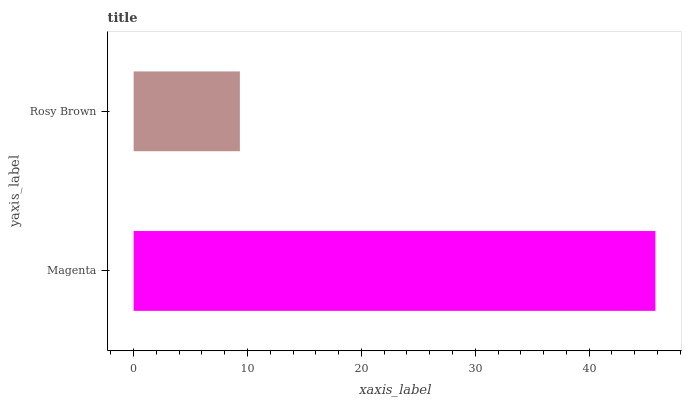Is Rosy Brown the minimum?
Answer yes or no. Yes. Is Magenta the maximum?
Answer yes or no. Yes. Is Rosy Brown the maximum?
Answer yes or no. No. Is Magenta greater than Rosy Brown?
Answer yes or no. Yes. Is Rosy Brown less than Magenta?
Answer yes or no. Yes. Is Rosy Brown greater than Magenta?
Answer yes or no. No. Is Magenta less than Rosy Brown?
Answer yes or no. No. Is Magenta the high median?
Answer yes or no. Yes. Is Rosy Brown the low median?
Answer yes or no. Yes. Is Rosy Brown the high median?
Answer yes or no. No. Is Magenta the low median?
Answer yes or no. No. 